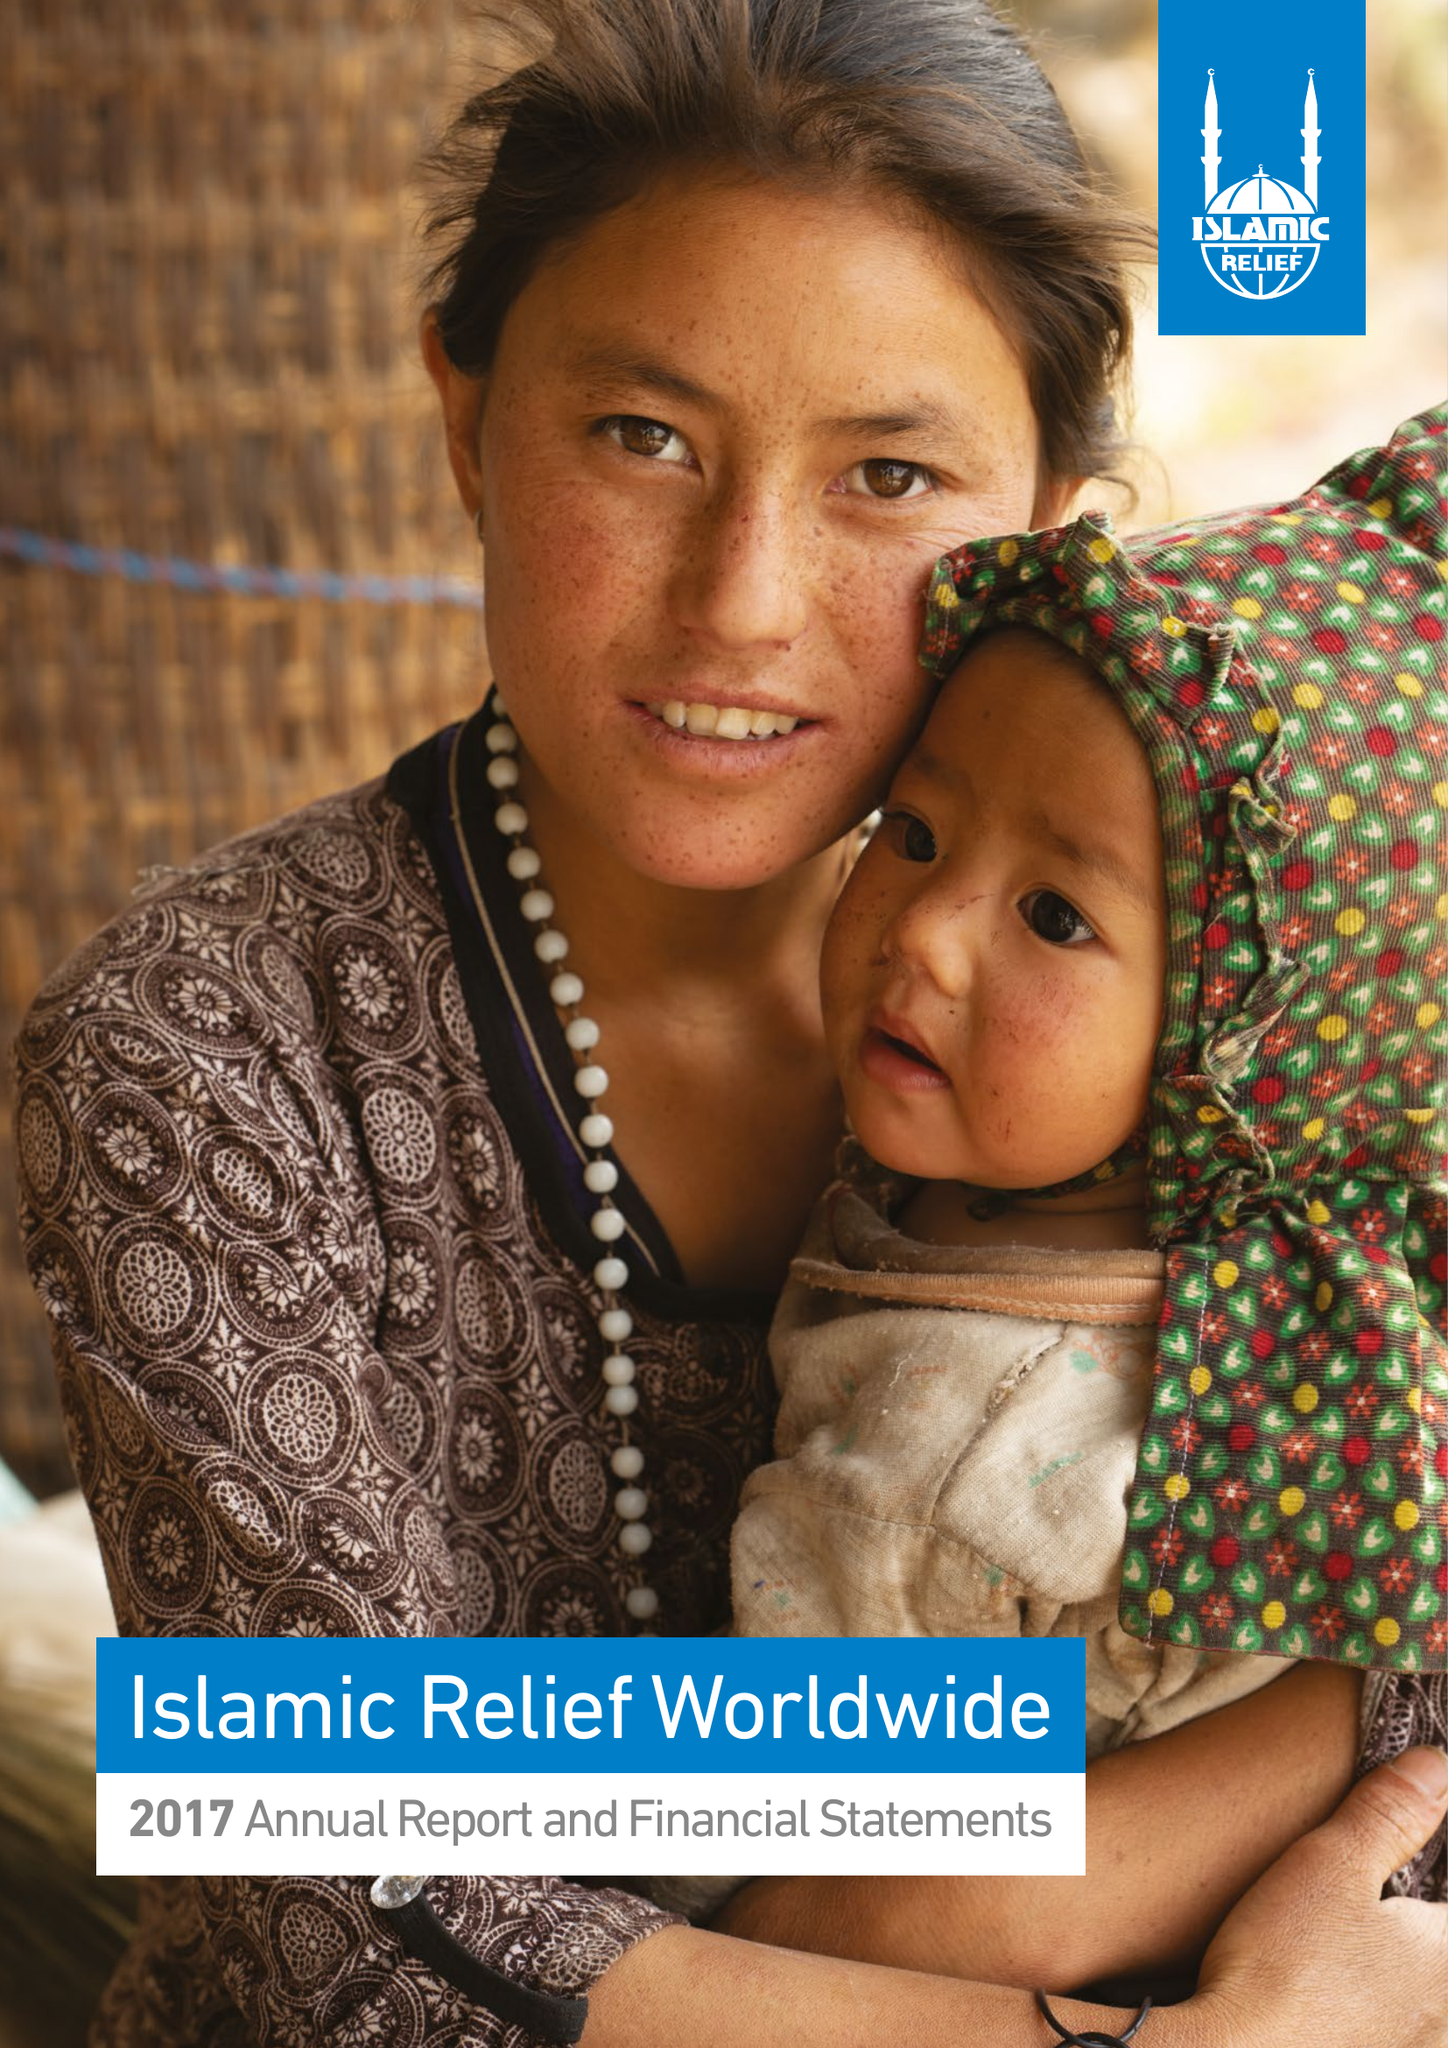What is the value for the income_annually_in_british_pounds?
Answer the question using a single word or phrase. 126546524.00 